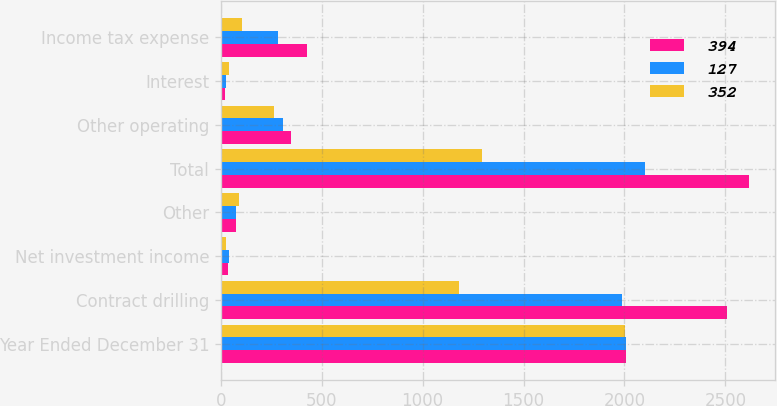Convert chart. <chart><loc_0><loc_0><loc_500><loc_500><stacked_bar_chart><ecel><fcel>Year Ended December 31<fcel>Contract drilling<fcel>Net investment income<fcel>Other<fcel>Total<fcel>Other operating<fcel>Interest<fcel>Income tax expense<nl><fcel>394<fcel>2007<fcel>2506<fcel>34<fcel>77<fcel>2616<fcel>348<fcel>19<fcel>429<nl><fcel>127<fcel>2006<fcel>1987<fcel>38<fcel>77<fcel>2102<fcel>306<fcel>24<fcel>285<nl><fcel>352<fcel>2005<fcel>1179<fcel>26<fcel>89<fcel>1293<fcel>262<fcel>42<fcel>104<nl></chart> 